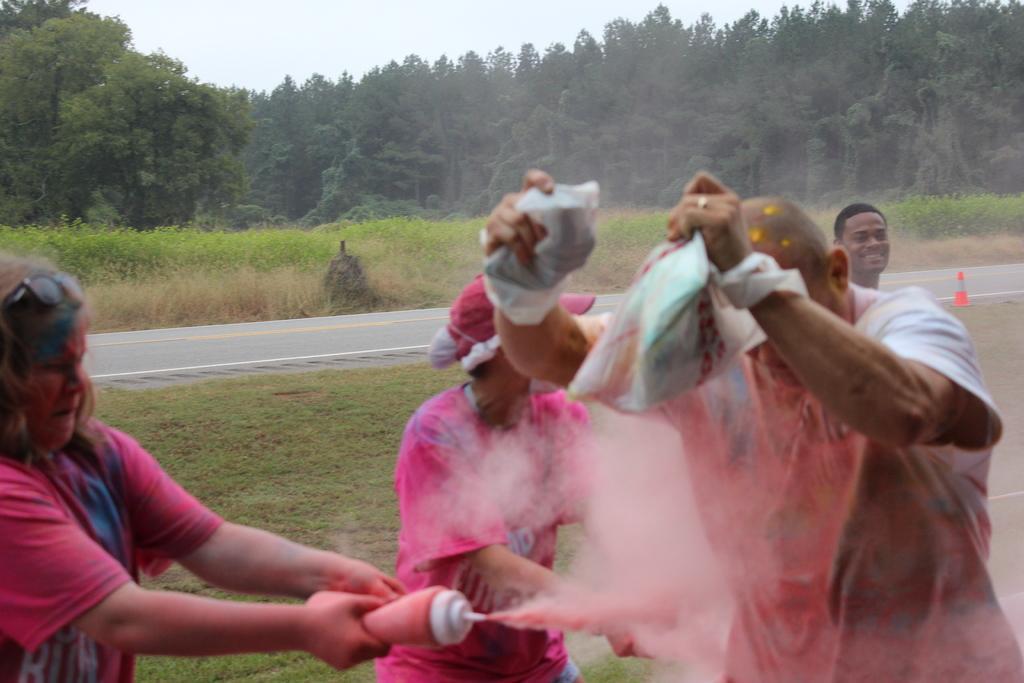How would you summarize this image in a sentence or two? In this picture,we see four people are standing. The woman on the left side is holding a bottle containing rangoli colors. The man in front of the picture is holding the plastic bags containing the rangoli colors. They are playing the holi. At the bottom, we see the grass. Behind them, we see the road and a traffic stopper in white and orange color. There are trees in the background. At the top, we see the sky. 